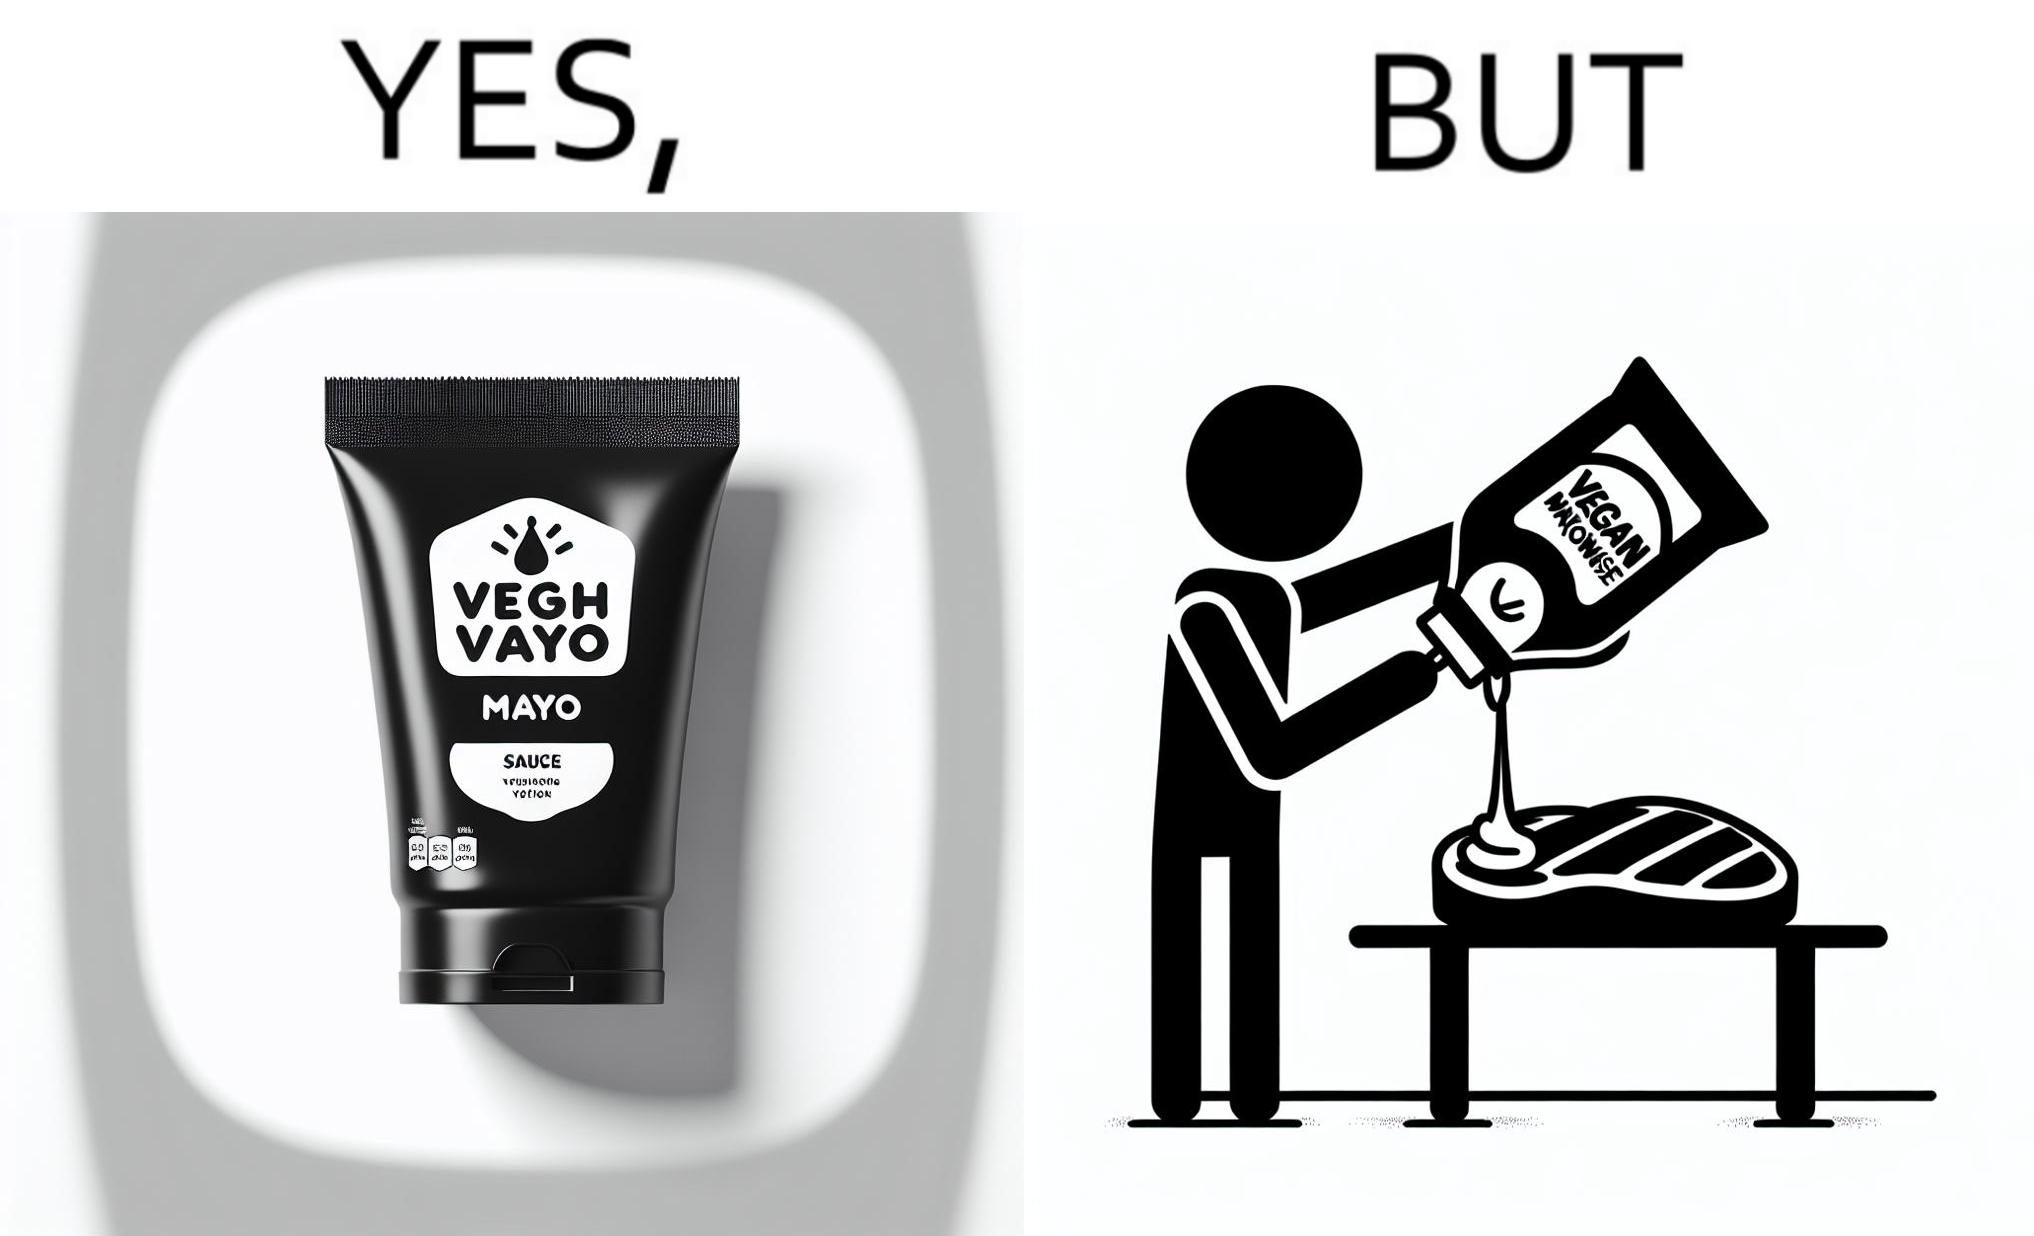Describe the satirical element in this image. The image is ironical, as vegan mayo sauce is being poured on rib steak, which is non-vegetarian. The person might as well just use normal mayo sauce instead. 